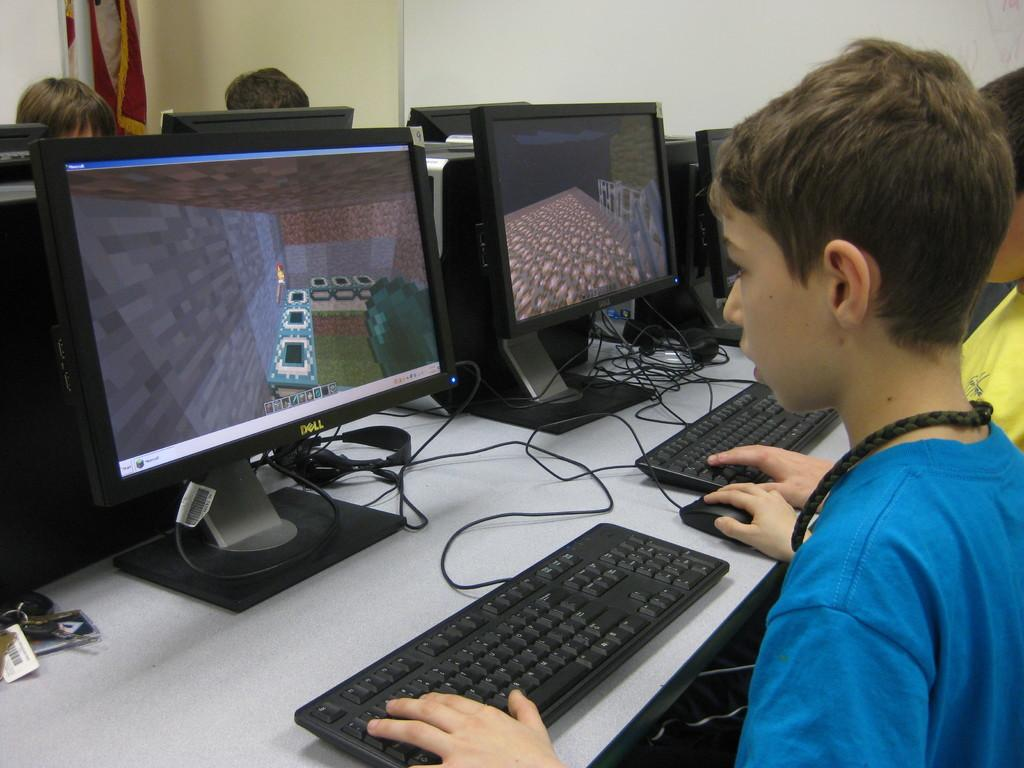<image>
Relay a brief, clear account of the picture shown. young people playing computer games on Dell computers 